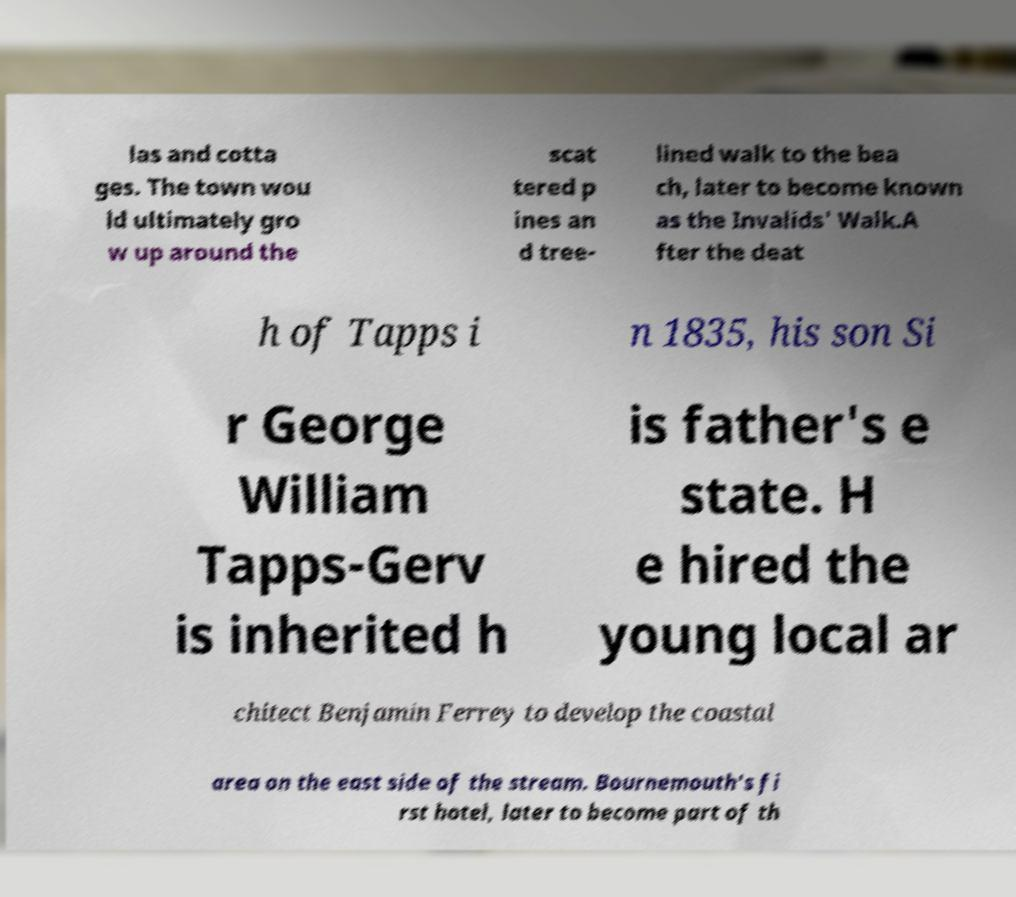Please identify and transcribe the text found in this image. las and cotta ges. The town wou ld ultimately gro w up around the scat tered p ines an d tree- lined walk to the bea ch, later to become known as the Invalids' Walk.A fter the deat h of Tapps i n 1835, his son Si r George William Tapps-Gerv is inherited h is father's e state. H e hired the young local ar chitect Benjamin Ferrey to develop the coastal area on the east side of the stream. Bournemouth's fi rst hotel, later to become part of th 